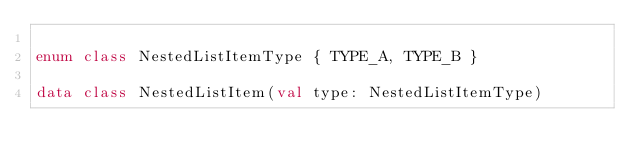<code> <loc_0><loc_0><loc_500><loc_500><_Kotlin_>
enum class NestedListItemType { TYPE_A, TYPE_B }

data class NestedListItem(val type: NestedListItemType)</code> 